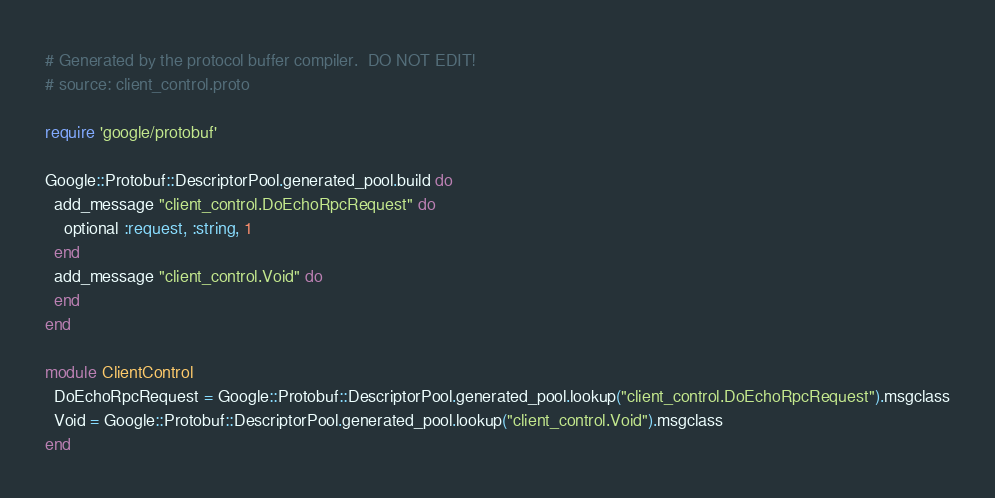<code> <loc_0><loc_0><loc_500><loc_500><_Ruby_># Generated by the protocol buffer compiler.  DO NOT EDIT!
# source: client_control.proto

require 'google/protobuf'

Google::Protobuf::DescriptorPool.generated_pool.build do
  add_message "client_control.DoEchoRpcRequest" do
    optional :request, :string, 1
  end
  add_message "client_control.Void" do
  end
end

module ClientControl
  DoEchoRpcRequest = Google::Protobuf::DescriptorPool.generated_pool.lookup("client_control.DoEchoRpcRequest").msgclass
  Void = Google::Protobuf::DescriptorPool.generated_pool.lookup("client_control.Void").msgclass
end
</code> 